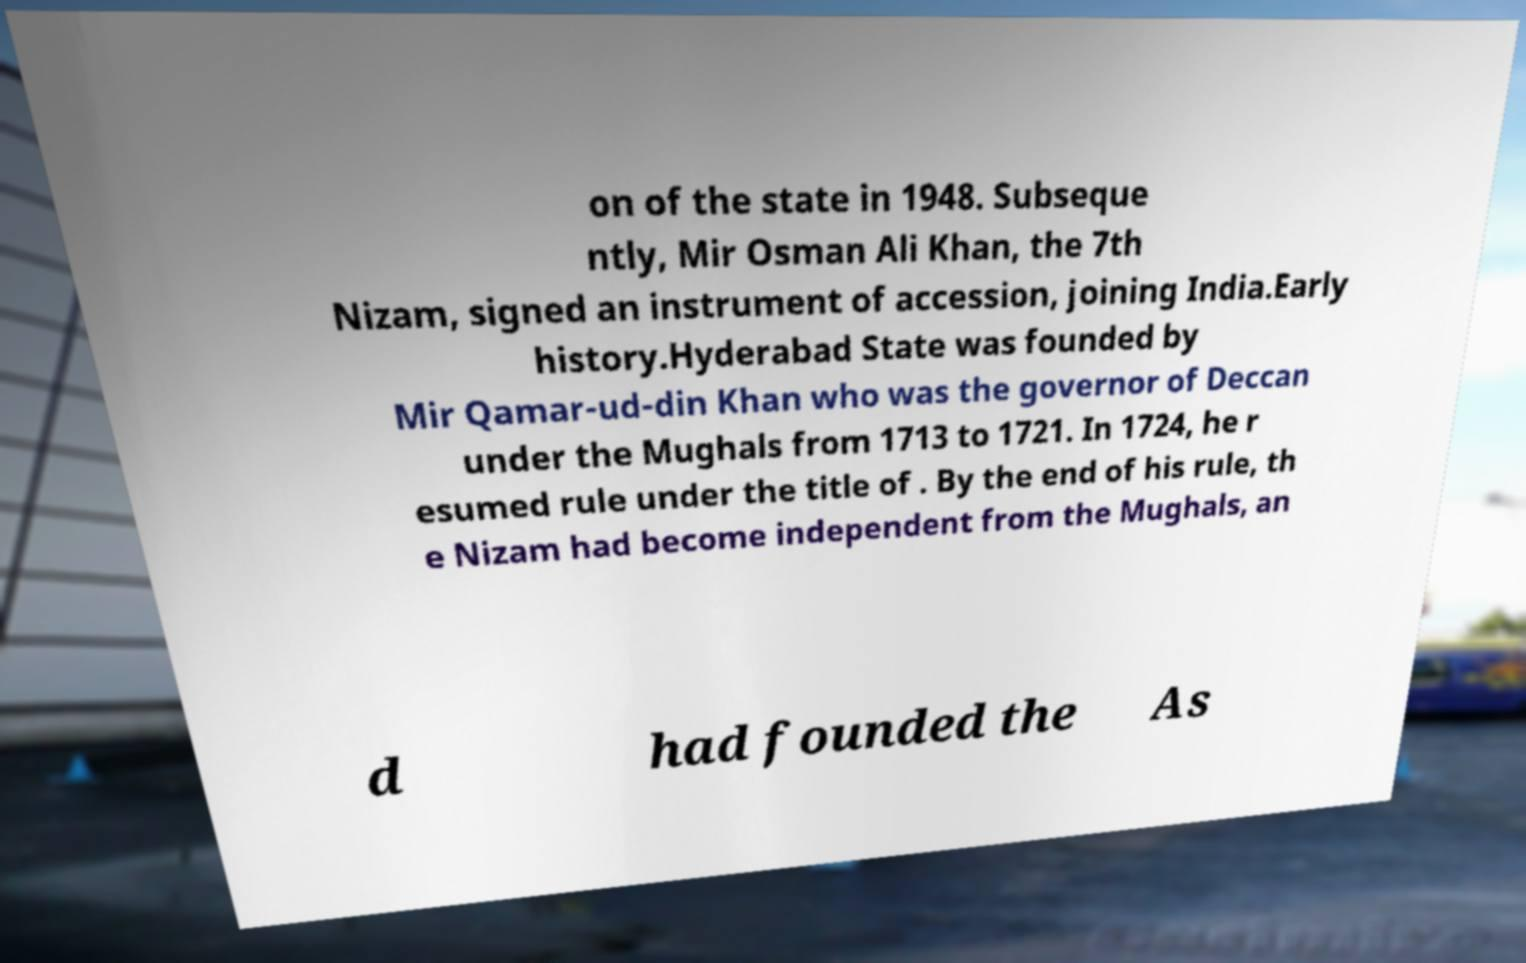Please read and relay the text visible in this image. What does it say? on of the state in 1948. Subseque ntly, Mir Osman Ali Khan, the 7th Nizam, signed an instrument of accession, joining India.Early history.Hyderabad State was founded by Mir Qamar-ud-din Khan who was the governor of Deccan under the Mughals from 1713 to 1721. In 1724, he r esumed rule under the title of . By the end of his rule, th e Nizam had become independent from the Mughals, an d had founded the As 